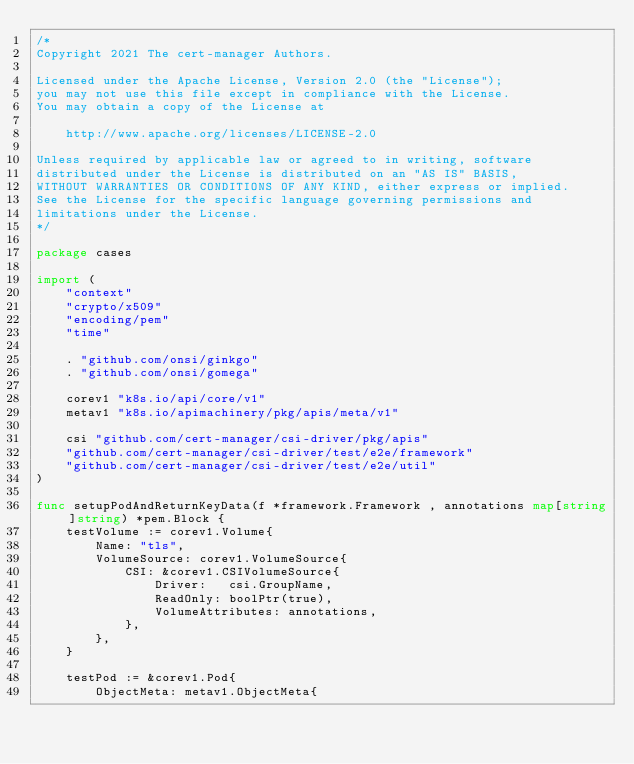Convert code to text. <code><loc_0><loc_0><loc_500><loc_500><_Go_>/*
Copyright 2021 The cert-manager Authors.

Licensed under the Apache License, Version 2.0 (the "License");
you may not use this file except in compliance with the License.
You may obtain a copy of the License at

    http://www.apache.org/licenses/LICENSE-2.0

Unless required by applicable law or agreed to in writing, software
distributed under the License is distributed on an "AS IS" BASIS,
WITHOUT WARRANTIES OR CONDITIONS OF ANY KIND, either express or implied.
See the License for the specific language governing permissions and
limitations under the License.
*/

package cases

import (
	"context"
	"crypto/x509"
	"encoding/pem"
	"time"

	. "github.com/onsi/ginkgo"
	. "github.com/onsi/gomega"

	corev1 "k8s.io/api/core/v1"
	metav1 "k8s.io/apimachinery/pkg/apis/meta/v1"

	csi "github.com/cert-manager/csi-driver/pkg/apis"
	"github.com/cert-manager/csi-driver/test/e2e/framework"
	"github.com/cert-manager/csi-driver/test/e2e/util"
)

func setupPodAndReturnKeyData(f *framework.Framework , annotations map[string]string) *pem.Block {
	testVolume := corev1.Volume{
		Name: "tls",
		VolumeSource: corev1.VolumeSource{
			CSI: &corev1.CSIVolumeSource{
				Driver:   csi.GroupName,
				ReadOnly: boolPtr(true),
				VolumeAttributes: annotations,
			},
		},
	}

	testPod := &corev1.Pod{
		ObjectMeta: metav1.ObjectMeta{</code> 